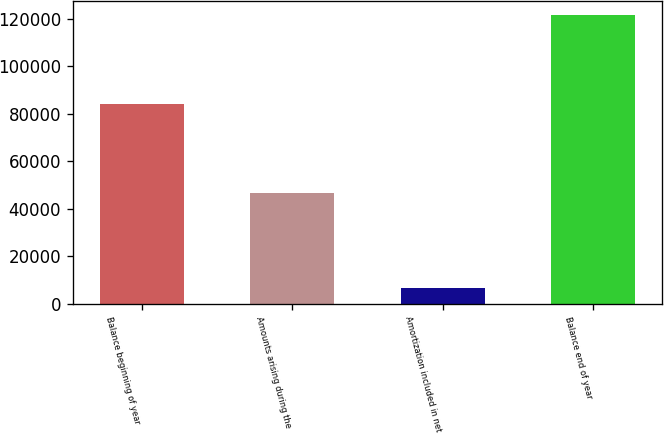<chart> <loc_0><loc_0><loc_500><loc_500><bar_chart><fcel>Balance beginning of year<fcel>Amounts arising during the<fcel>Amortization included in net<fcel>Balance end of year<nl><fcel>84122<fcel>46580<fcel>6670<fcel>121522<nl></chart> 